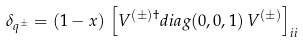Convert formula to latex. <formula><loc_0><loc_0><loc_500><loc_500>\delta _ { q ^ { \pm } } = ( 1 - x ) \, \left [ V ^ { ( \pm ) \dagger } d i a g ( 0 , 0 , 1 ) \, V ^ { ( \pm ) } \right ] _ { i i }</formula> 